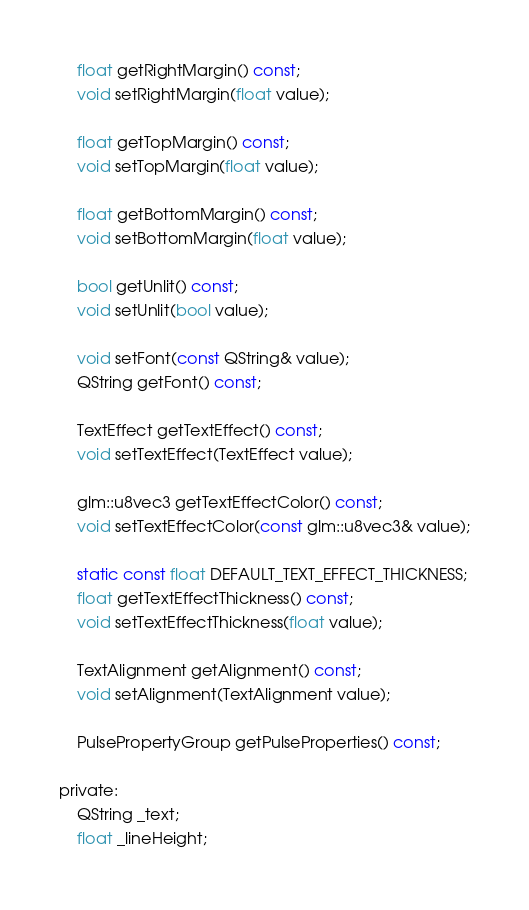Convert code to text. <code><loc_0><loc_0><loc_500><loc_500><_C_>    float getRightMargin() const;
    void setRightMargin(float value);

    float getTopMargin() const;
    void setTopMargin(float value);

    float getBottomMargin() const;
    void setBottomMargin(float value);

    bool getUnlit() const;
    void setUnlit(bool value);

    void setFont(const QString& value);
    QString getFont() const;

    TextEffect getTextEffect() const;
    void setTextEffect(TextEffect value);

    glm::u8vec3 getTextEffectColor() const;
    void setTextEffectColor(const glm::u8vec3& value);

    static const float DEFAULT_TEXT_EFFECT_THICKNESS;
    float getTextEffectThickness() const;
    void setTextEffectThickness(float value);

    TextAlignment getAlignment() const;
    void setAlignment(TextAlignment value);

    PulsePropertyGroup getPulseProperties() const;

private:
    QString _text;
    float _lineHeight;</code> 